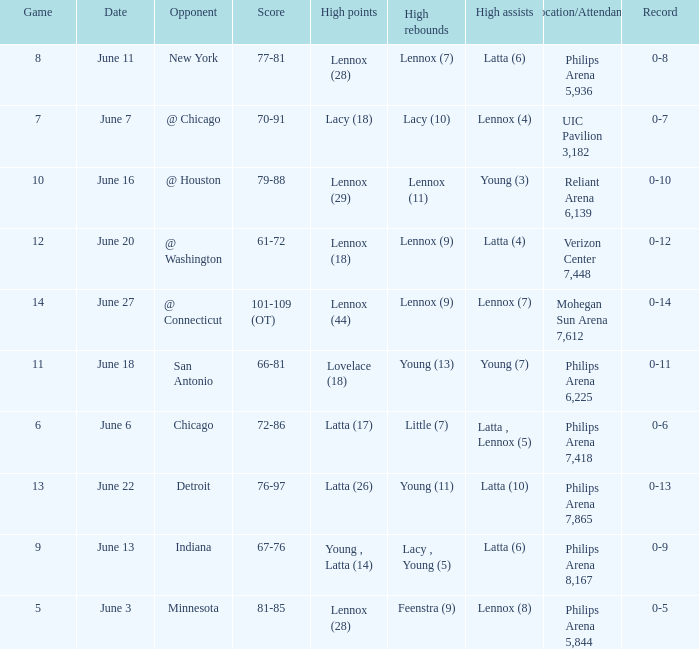Who made the highest assist in the game that scored 79-88? Young (3). 